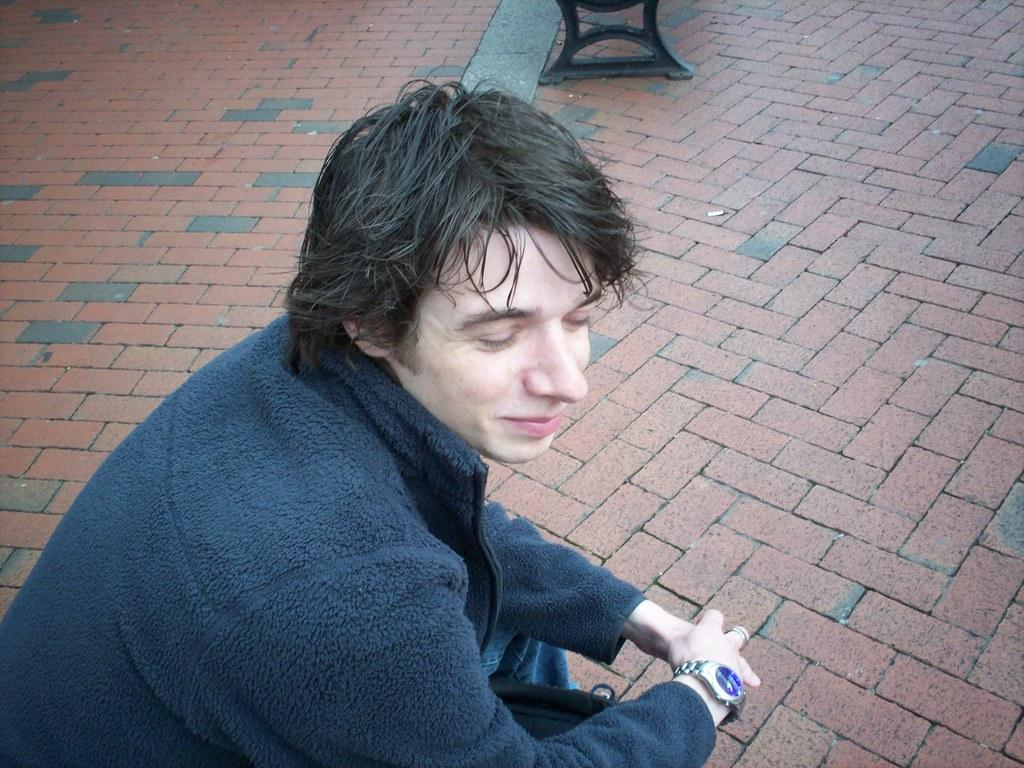Who is present in the image? There is a man in the image. What can be seen beneath the man's feet? The floor is visible in the image. What type of event is the yak attending in the image? There is no yak present in the image, so it cannot be attending any event. 